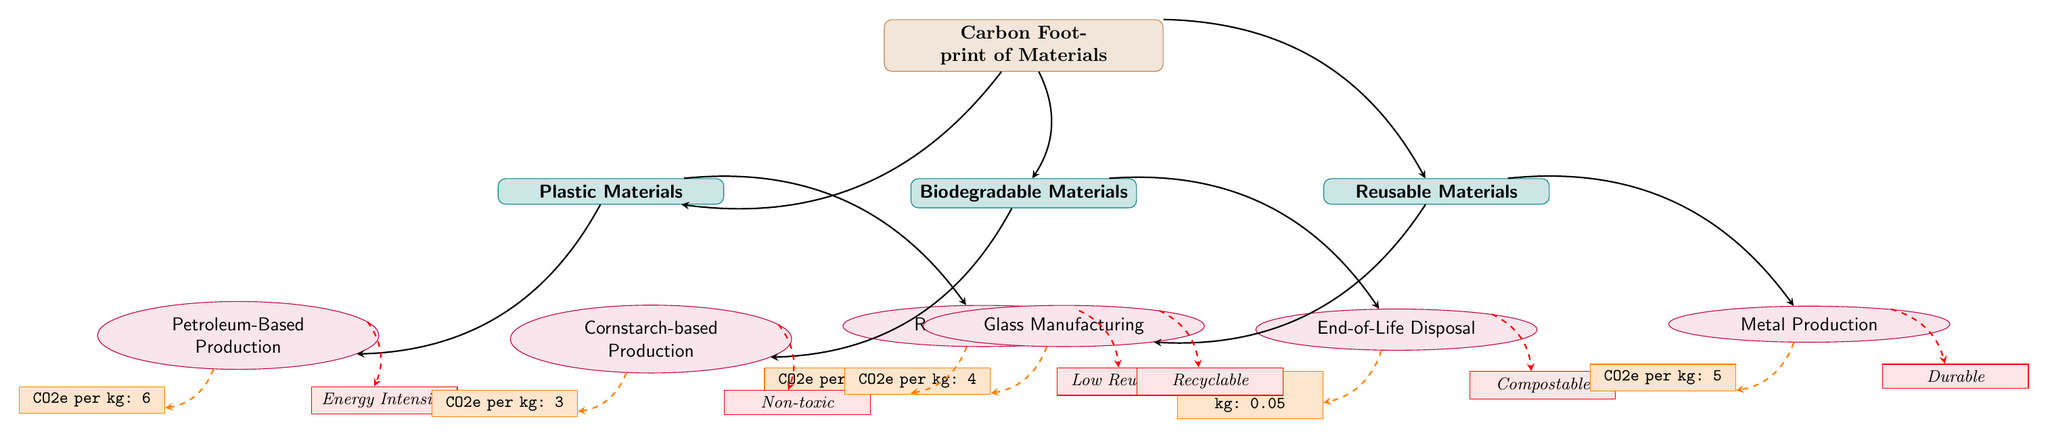What is the CO2e per kg for petroleum-based production? The diagram indicates that the CO2e per kg for petroleum-based production is specifically labeled next to the node for that subcategory. Referring to the metric under the “Petroleum-Based Production” subcategory reveals the value is 6.
Answer: 6 What is the environmental indicator for glass manufacturing? The environmental indicator is shown next to the metric for glass manufacturing. By checking the connection from the glass manufacturing subcategory to the corresponding indicator node, it states "Recyclable."
Answer: Recyclable How many main categories are there in this diagram? The diagram categorizes materials into three main types: Plastic Materials, Biodegradable Materials, and Reusable Materials. Counting these names provides a total of three categories.
Answer: 3 Which material has the lowest CO2e per kg value? To find the lowest value, compare the values shown in each subcategory: Petroleum-Based Production (6), Recycling Process (2), Cornstarch-based Production (3), End-of-Life Disposal (0.05), Glass Manufacturing (4), and Metal Production (5). The End-of-Life Disposal at 0.05 is the lowest.
Answer: 0.05 Which alternative material has a non-toxic production process? The diagram specifies the environmental indicators for the subcategory of Biodegradable Materials. By checking the corresponding metric and indicator labeled next to Cornstarch-based Production, it shows "Non-toxic."
Answer: Non-toxic What type of manufacturing has an energy-intensive production indicated? Referring to the environmental indicator under the Petroleum-Based Production subcategory, it clearly states that this process is "Energy Intensive."
Answer: Energy Intensive What category does the metric CO2e per kg: 0.05 belong to? Looking at the metric CO2e per kg: 0.05, we can trace it back to the End-of-Life Disposal subcategory. Therefore, this metric is associated with Biodegradable Materials.
Answer: Biodegradable Materials What is the CO2e per kg metric for reusable materials combined? From the two subcategories under Reusable Materials (Glass Manufacturing and Metal Production), the metrics are 4 and 5 respectively. There isn’t a singular combined metric, but these values can be noted individually without summing them as the diagram doesn't indicate an aggregate value.
Answer: Not applicable 